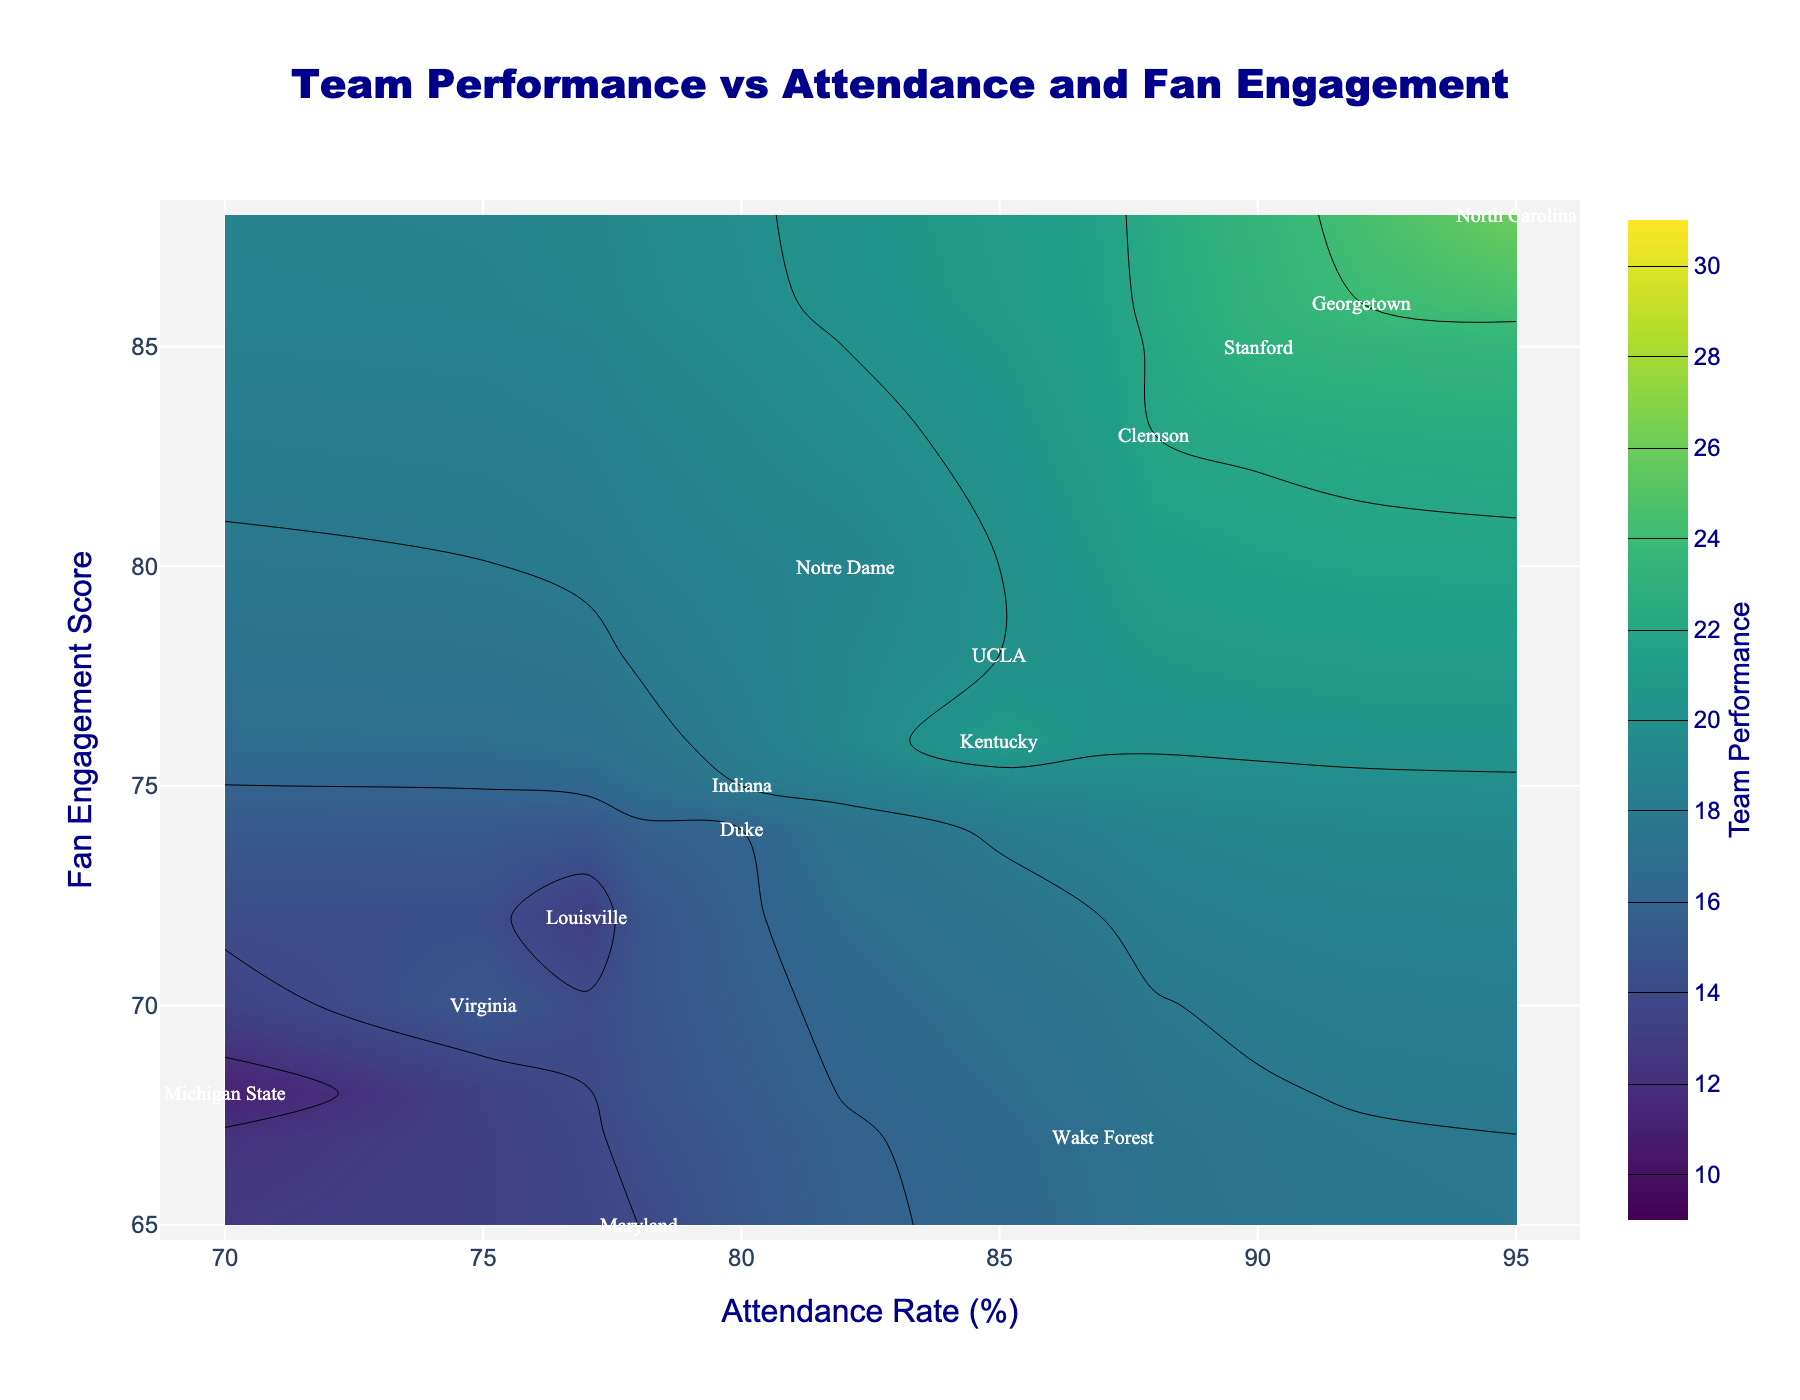What is the title of the plot? The title of the plot is located at the top center of the figure. It reads: "Team Performance vs Attendance and Fan Engagement".
Answer: Team Performance vs Attendance and Fan Engagement What are the x-axis and y-axis titles? The x-axis title is located along the bottom of the plot, and the y-axis title is on the left side. The x-axis title is "Attendance Rate (%)" and the y-axis title is "Fan Engagement Score".
Answer: Attendance Rate (%) and Fan Engagement Score Which team has the highest Attendance Rate and what is its Team Performance? By looking at the contour plot, we find the highest Attendance Rate is 95%, and the team corresponding to this value is "North Carolina". The Team Performance for North Carolina is 26.
Answer: North Carolina and 26 How does the Team Performance of Kentucky compare to that of Stanford? Locate the annotations for Kentucky and Stanford on the plot. Kentucky has a Team Performance of 21, while Stanford has a Team Performance of 23. Comparing these, Stanford's Team Performance is higher by 2 points.
Answer: Stanford's is higher by 2 points Which team has the lowest Fan Engagement Score and what is its respective Attendance Rate? Find the point with the lowest Fan Engagement Score which is 65. The team corresponding to this value is Maryland, and its Attendance Rate is 78%.
Answer: Maryland and 78% What is the range of the Team Performance values in the plot? To determine the range, identify the minimum and maximum Team Performance values in the plot. The minimum value is 11 (Michigan State) and the maximum is 26 (North Carolina). The range is therefore 26 - 11 = 15.
Answer: 15 What is the average Attendance Rate for the teams shown? Sum up all the Attendance Rates: 85+90+95+80+75+82+78+88+87+80+77+70+85+92 = 1164. There are 14 teams, so the average is 1164 / 14 ≈ 83.14.
Answer: 83.14 Considering both Attendance Rate and Fan Engagement Score, which team has the best overall combination for high Team Performance? It is most effective to find a team with both high Attendance Rate and Fan Engagement Score. "North Carolina" with an Attendance Rate of 95% and Fan Engagement Score of 88, resulting in the highest Team Performance of 26, stands out.
Answer: North Carolina Which two teams have very similar Attendance Rates but differ significantly in their Fan Engagement Scores? Observe closely: Clemson (88%) and Wake Forest (87%) have close Attendance Rates. However, their Fan Engagement Scores differ significantly, with Clemson at 83 and Wake Forest at 67.
Answer: Clemson and Wake Forest 